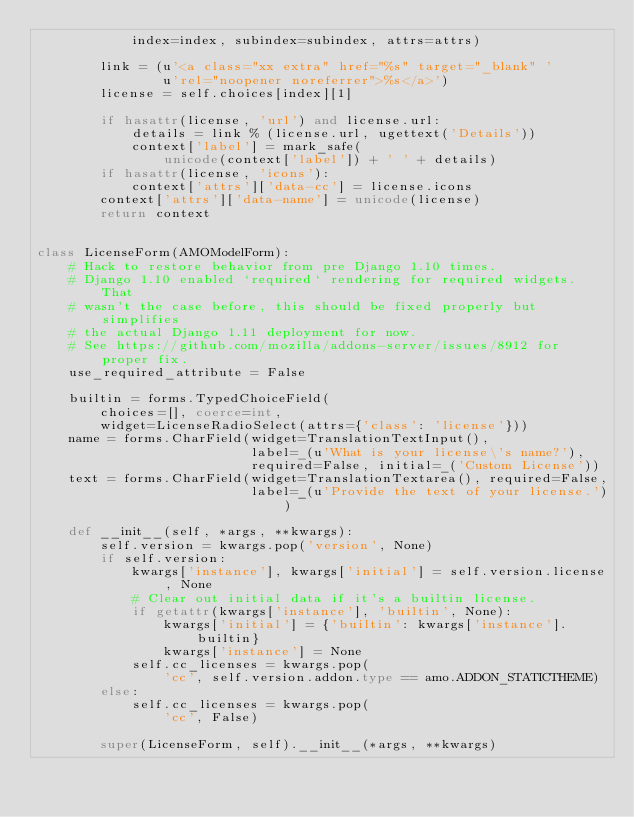<code> <loc_0><loc_0><loc_500><loc_500><_Python_>            index=index, subindex=subindex, attrs=attrs)

        link = (u'<a class="xx extra" href="%s" target="_blank" '
                u'rel="noopener noreferrer">%s</a>')
        license = self.choices[index][1]

        if hasattr(license, 'url') and license.url:
            details = link % (license.url, ugettext('Details'))
            context['label'] = mark_safe(
                unicode(context['label']) + ' ' + details)
        if hasattr(license, 'icons'):
            context['attrs']['data-cc'] = license.icons
        context['attrs']['data-name'] = unicode(license)
        return context


class LicenseForm(AMOModelForm):
    # Hack to restore behavior from pre Django 1.10 times.
    # Django 1.10 enabled `required` rendering for required widgets. That
    # wasn't the case before, this should be fixed properly but simplifies
    # the actual Django 1.11 deployment for now.
    # See https://github.com/mozilla/addons-server/issues/8912 for proper fix.
    use_required_attribute = False

    builtin = forms.TypedChoiceField(
        choices=[], coerce=int,
        widget=LicenseRadioSelect(attrs={'class': 'license'}))
    name = forms.CharField(widget=TranslationTextInput(),
                           label=_(u'What is your license\'s name?'),
                           required=False, initial=_('Custom License'))
    text = forms.CharField(widget=TranslationTextarea(), required=False,
                           label=_(u'Provide the text of your license.'))

    def __init__(self, *args, **kwargs):
        self.version = kwargs.pop('version', None)
        if self.version:
            kwargs['instance'], kwargs['initial'] = self.version.license, None
            # Clear out initial data if it's a builtin license.
            if getattr(kwargs['instance'], 'builtin', None):
                kwargs['initial'] = {'builtin': kwargs['instance'].builtin}
                kwargs['instance'] = None
            self.cc_licenses = kwargs.pop(
                'cc', self.version.addon.type == amo.ADDON_STATICTHEME)
        else:
            self.cc_licenses = kwargs.pop(
                'cc', False)

        super(LicenseForm, self).__init__(*args, **kwargs)</code> 